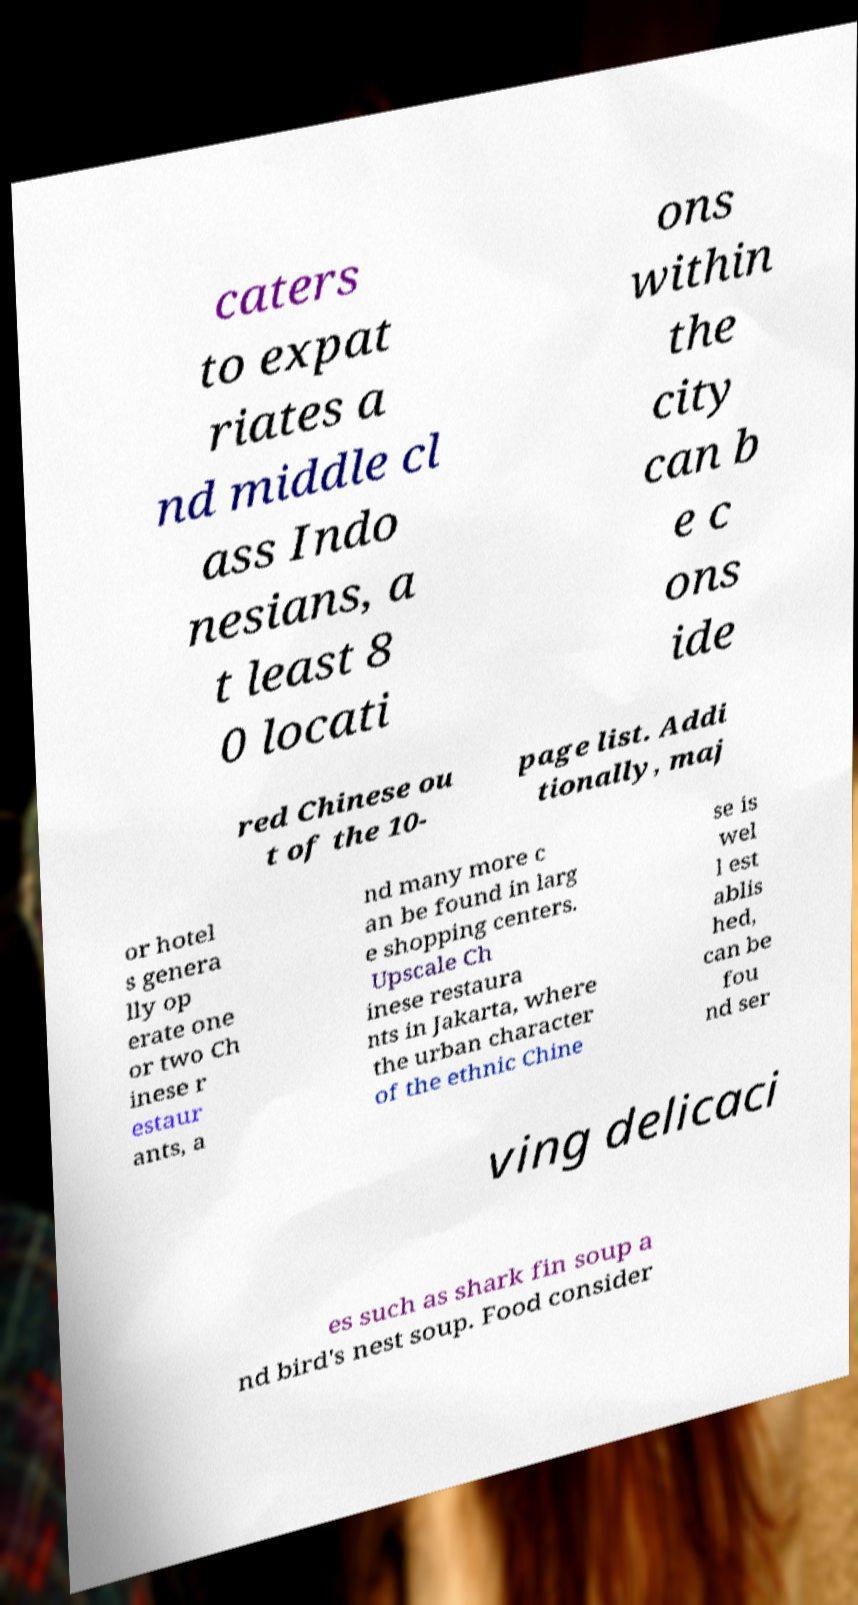Could you extract and type out the text from this image? caters to expat riates a nd middle cl ass Indo nesians, a t least 8 0 locati ons within the city can b e c ons ide red Chinese ou t of the 10- page list. Addi tionally, maj or hotel s genera lly op erate one or two Ch inese r estaur ants, a nd many more c an be found in larg e shopping centers. Upscale Ch inese restaura nts in Jakarta, where the urban character of the ethnic Chine se is wel l est ablis hed, can be fou nd ser ving delicaci es such as shark fin soup a nd bird's nest soup. Food consider 